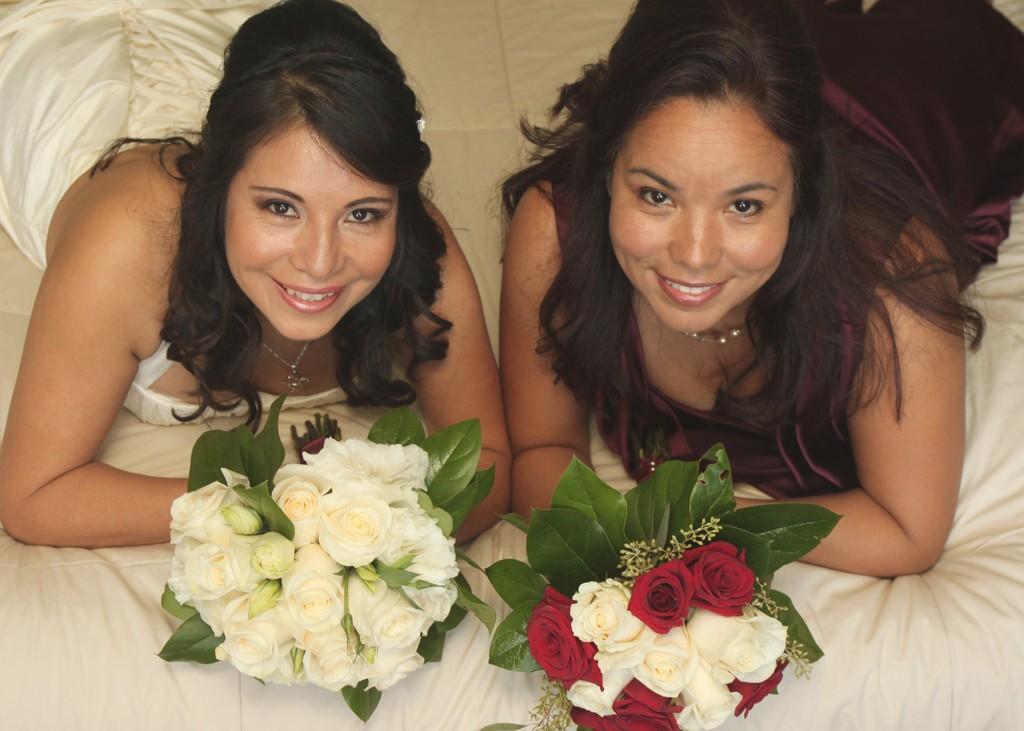How would you summarize this image in a sentence or two? In this image there are two women one on the left side and one on the right side. Those both are holding the set of flower. 